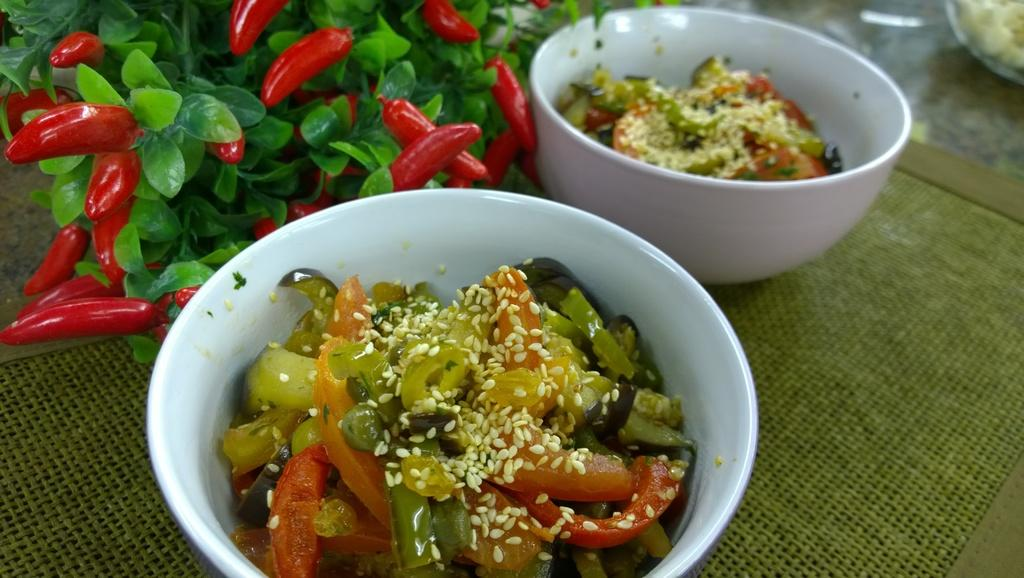What is the color of the mat in the image? The mat in the image is green. How many bowls are placed on the mat? Two bowls are placed on the mat. What can be seen on the mat besides the bowls? There are leaves and red color chilies on the mat. What is inside the bowls? There are food items in the bowls. What type of plant is growing on the page in the image? There is no page or plant present in the image. 